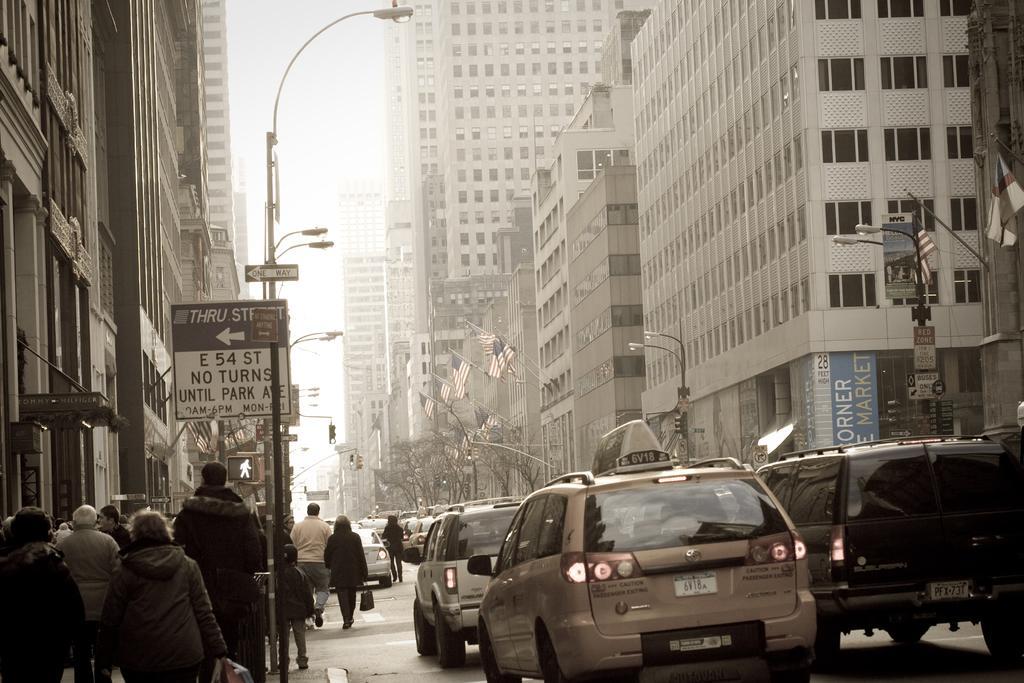In one or two sentences, can you explain what this image depicts? In this image we can see a group of buildings with windows. We can also see the street poles, a group of people and some vehicles on the ground, the flags, trees, the sign boards with some text on them and the sky. 